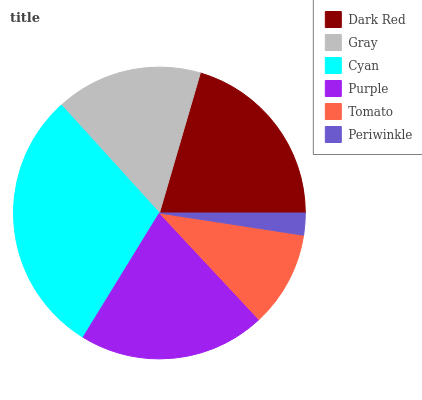Is Periwinkle the minimum?
Answer yes or no. Yes. Is Cyan the maximum?
Answer yes or no. Yes. Is Gray the minimum?
Answer yes or no. No. Is Gray the maximum?
Answer yes or no. No. Is Dark Red greater than Gray?
Answer yes or no. Yes. Is Gray less than Dark Red?
Answer yes or no. Yes. Is Gray greater than Dark Red?
Answer yes or no. No. Is Dark Red less than Gray?
Answer yes or no. No. Is Dark Red the high median?
Answer yes or no. Yes. Is Gray the low median?
Answer yes or no. Yes. Is Cyan the high median?
Answer yes or no. No. Is Dark Red the low median?
Answer yes or no. No. 